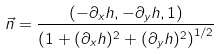Convert formula to latex. <formula><loc_0><loc_0><loc_500><loc_500>\vec { n } = \frac { ( - \partial _ { x } h , - \partial _ { y } h , 1 ) } { \left ( 1 + ( \partial _ { x } h ) ^ { 2 } + ( \partial _ { y } h ) ^ { 2 } \right ) ^ { 1 / 2 } }</formula> 